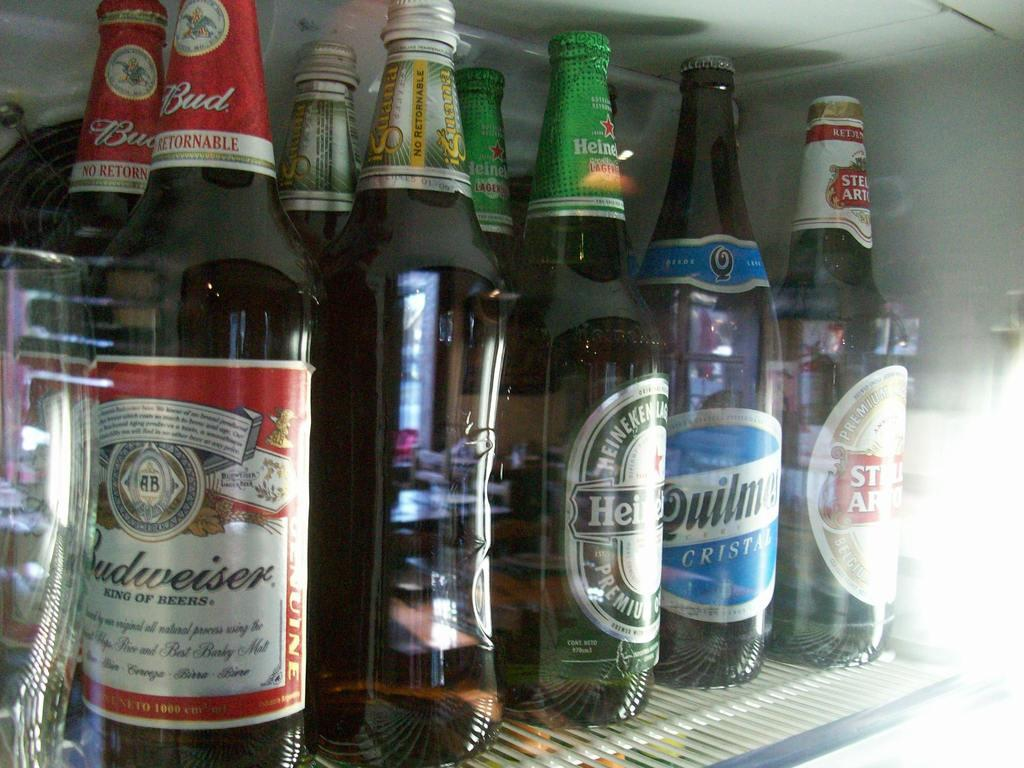What is the main subject of the image? The main subject of the image is many bottles. Where are the bottles located in the image? The bottles are on a freeze. How many sheep can be seen grazing near the dock in the image? There are no sheep or dock present in the image; it only features many bottles on a freeze. 